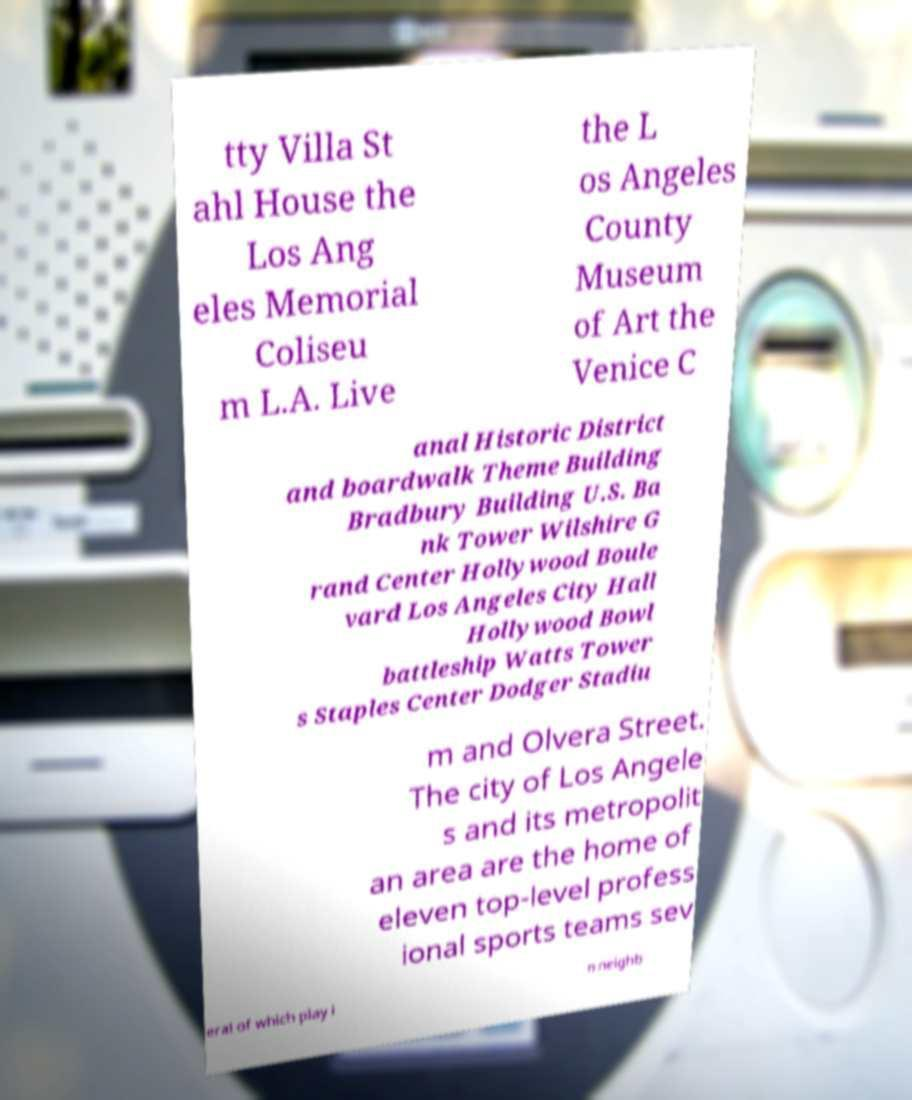Please read and relay the text visible in this image. What does it say? tty Villa St ahl House the Los Ang eles Memorial Coliseu m L.A. Live the L os Angeles County Museum of Art the Venice C anal Historic District and boardwalk Theme Building Bradbury Building U.S. Ba nk Tower Wilshire G rand Center Hollywood Boule vard Los Angeles City Hall Hollywood Bowl battleship Watts Tower s Staples Center Dodger Stadiu m and Olvera Street. The city of Los Angele s and its metropolit an area are the home of eleven top-level profess ional sports teams sev eral of which play i n neighb 